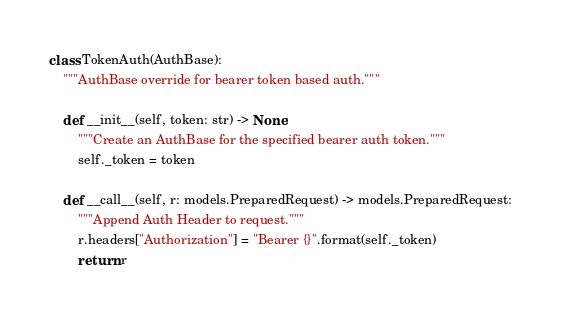Convert code to text. <code><loc_0><loc_0><loc_500><loc_500><_Python_>
class TokenAuth(AuthBase):
    """AuthBase override for bearer token based auth."""

    def __init__(self, token: str) -> None:
        """Create an AuthBase for the specified bearer auth token."""
        self._token = token

    def __call__(self, r: models.PreparedRequest) -> models.PreparedRequest:
        """Append Auth Header to request."""
        r.headers["Authorization"] = "Bearer {}".format(self._token)
        return r
</code> 